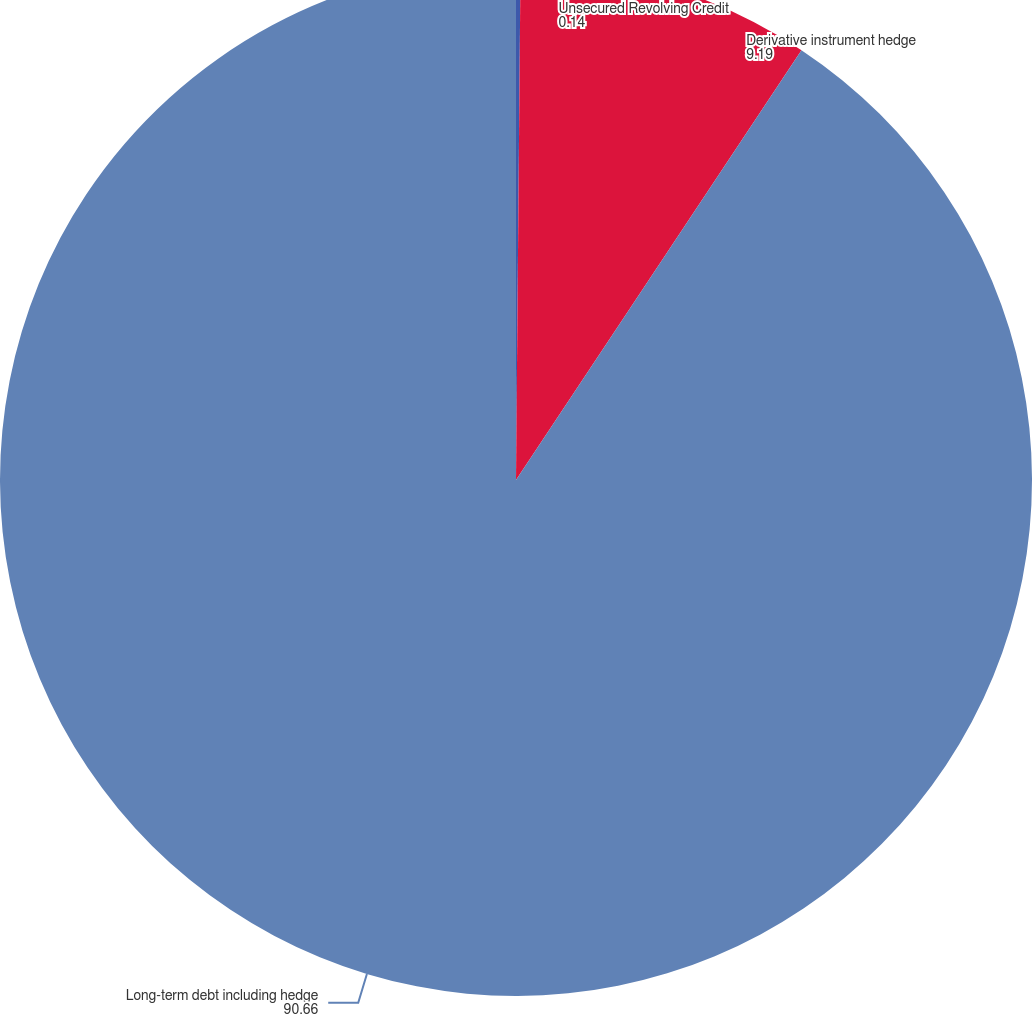Convert chart. <chart><loc_0><loc_0><loc_500><loc_500><pie_chart><fcel>Unsecured Revolving Credit<fcel>Derivative instrument hedge<fcel>Long-term debt including hedge<nl><fcel>0.14%<fcel>9.19%<fcel>90.66%<nl></chart> 